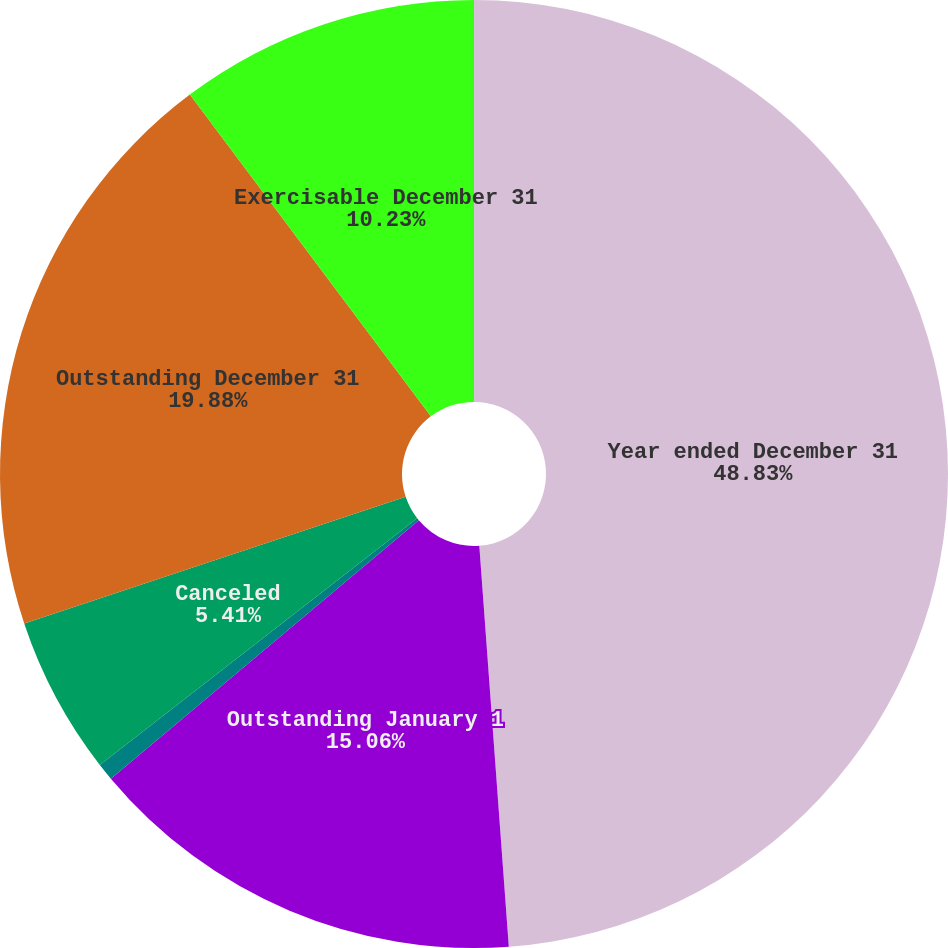Convert chart. <chart><loc_0><loc_0><loc_500><loc_500><pie_chart><fcel>Year ended December 31<fcel>Outstanding January 1<fcel>Exercised<fcel>Canceled<fcel>Outstanding December 31<fcel>Exercisable December 31<nl><fcel>48.83%<fcel>15.06%<fcel>0.59%<fcel>5.41%<fcel>19.88%<fcel>10.23%<nl></chart> 